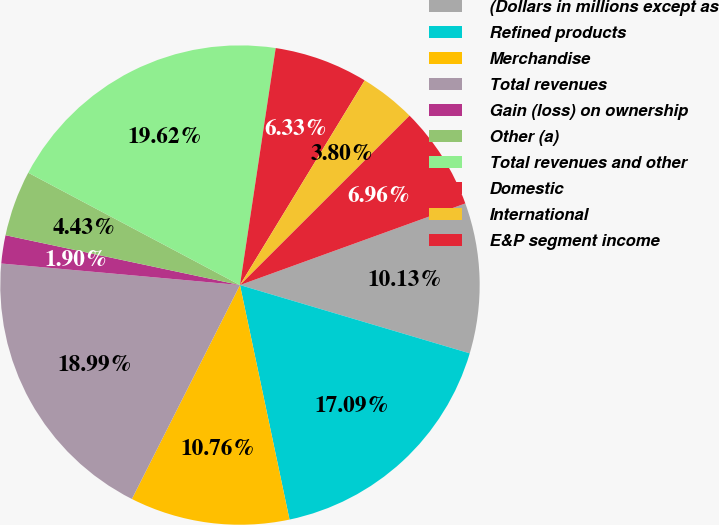Convert chart. <chart><loc_0><loc_0><loc_500><loc_500><pie_chart><fcel>(Dollars in millions except as<fcel>Refined products<fcel>Merchandise<fcel>Total revenues<fcel>Gain (loss) on ownership<fcel>Other (a)<fcel>Total revenues and other<fcel>Domestic<fcel>International<fcel>E&P segment income<nl><fcel>10.13%<fcel>17.09%<fcel>10.76%<fcel>18.99%<fcel>1.9%<fcel>4.43%<fcel>19.62%<fcel>6.33%<fcel>3.8%<fcel>6.96%<nl></chart> 